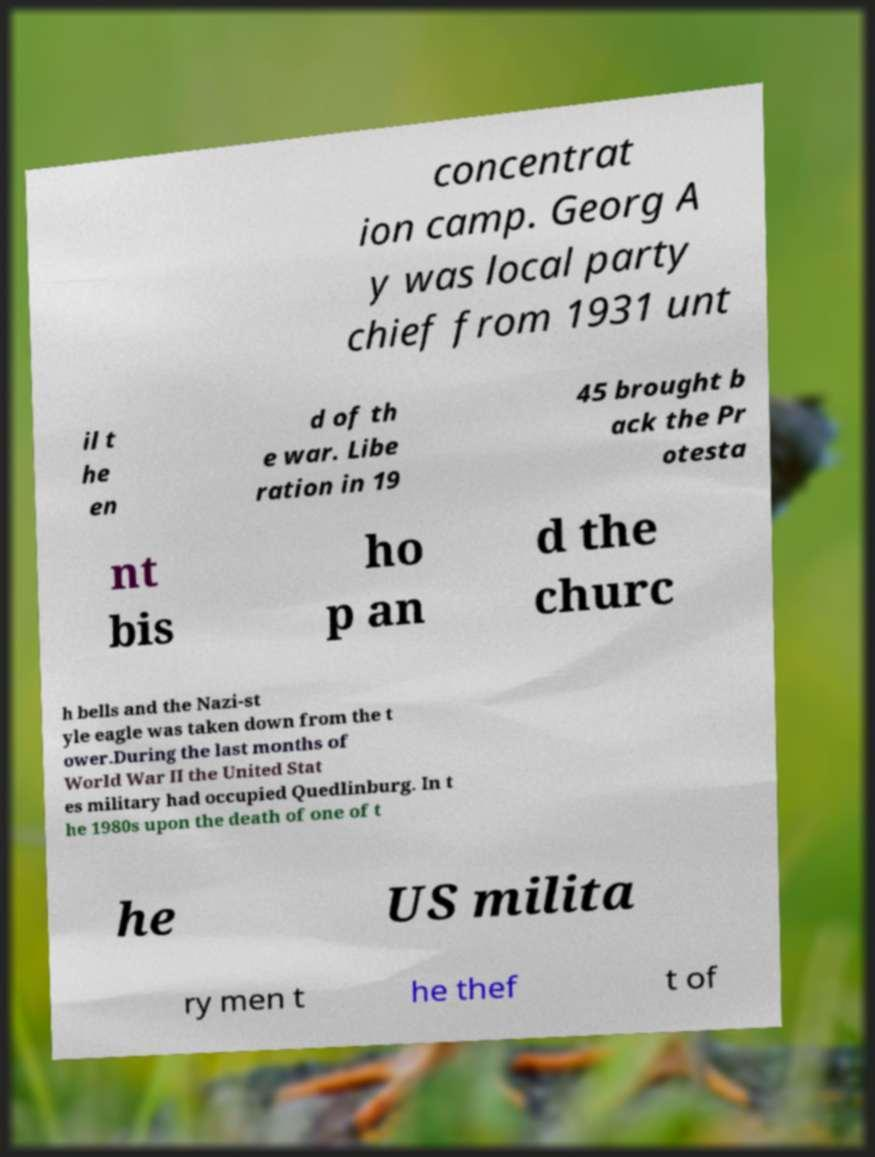Please read and relay the text visible in this image. What does it say? concentrat ion camp. Georg A y was local party chief from 1931 unt il t he en d of th e war. Libe ration in 19 45 brought b ack the Pr otesta nt bis ho p an d the churc h bells and the Nazi-st yle eagle was taken down from the t ower.During the last months of World War II the United Stat es military had occupied Quedlinburg. In t he 1980s upon the death of one of t he US milita ry men t he thef t of 